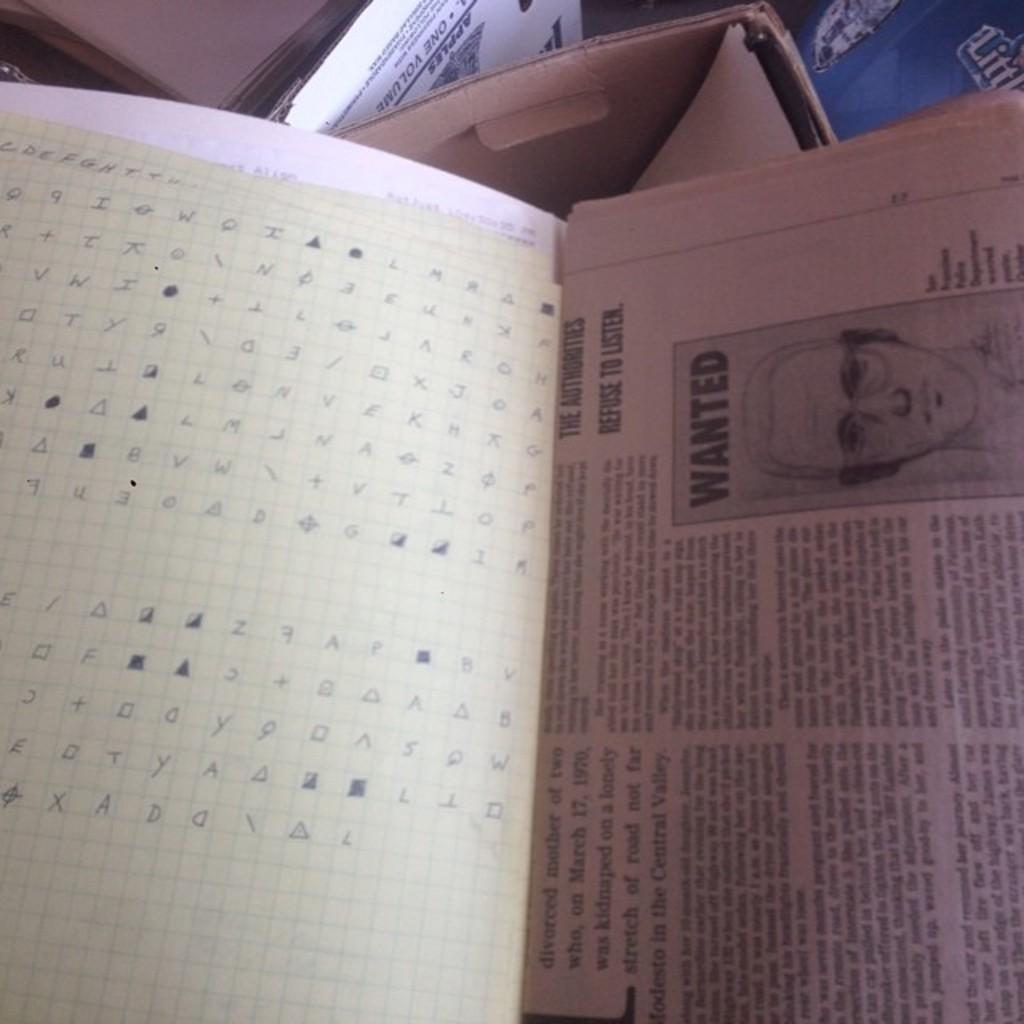<image>
Present a compact description of the photo's key features. a news paper article featuring a wanted poster with a mans' illustration on it. 